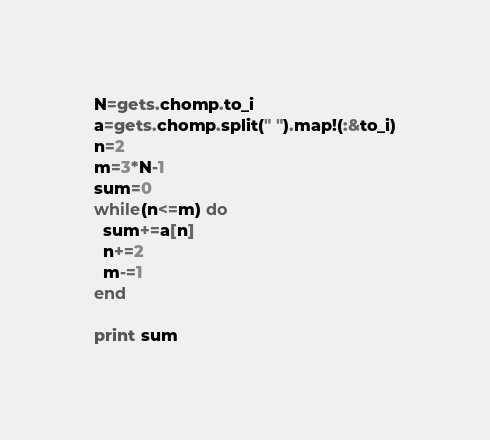<code> <loc_0><loc_0><loc_500><loc_500><_Ruby_>N=gets.chomp.to_i
a=gets.chomp.split(" ").map!(:&to_i)
n=2
m=3*N-1
sum=0
while(n<=m) do
  sum+=a[n]
  n+=2
  m-=1
end

print sum</code> 